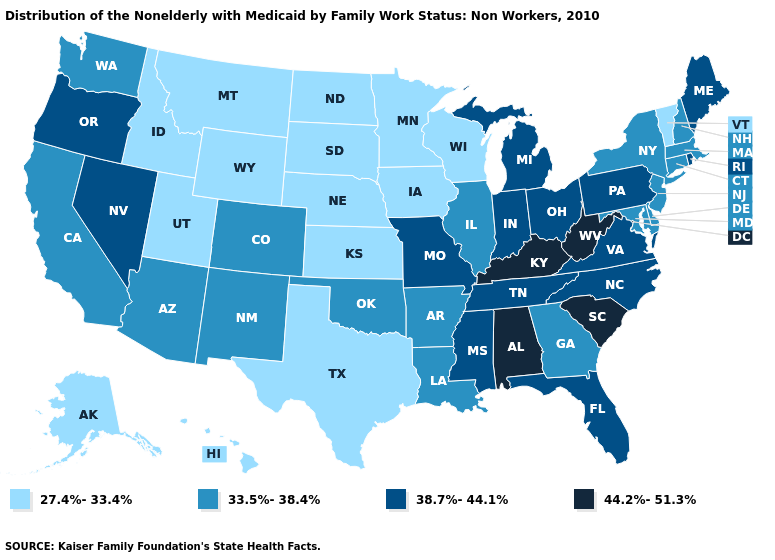Which states have the highest value in the USA?
Short answer required. Alabama, Kentucky, South Carolina, West Virginia. What is the value of Pennsylvania?
Give a very brief answer. 38.7%-44.1%. Does New York have the same value as Massachusetts?
Quick response, please. Yes. What is the value of Delaware?
Concise answer only. 33.5%-38.4%. Among the states that border Kentucky , which have the lowest value?
Short answer required. Illinois. Which states have the lowest value in the USA?
Keep it brief. Alaska, Hawaii, Idaho, Iowa, Kansas, Minnesota, Montana, Nebraska, North Dakota, South Dakota, Texas, Utah, Vermont, Wisconsin, Wyoming. Name the states that have a value in the range 38.7%-44.1%?
Answer briefly. Florida, Indiana, Maine, Michigan, Mississippi, Missouri, Nevada, North Carolina, Ohio, Oregon, Pennsylvania, Rhode Island, Tennessee, Virginia. What is the value of Maine?
Quick response, please. 38.7%-44.1%. Name the states that have a value in the range 33.5%-38.4%?
Write a very short answer. Arizona, Arkansas, California, Colorado, Connecticut, Delaware, Georgia, Illinois, Louisiana, Maryland, Massachusetts, New Hampshire, New Jersey, New Mexico, New York, Oklahoma, Washington. Does the first symbol in the legend represent the smallest category?
Answer briefly. Yes. Does Nevada have the highest value in the USA?
Give a very brief answer. No. Which states hav the highest value in the Northeast?
Answer briefly. Maine, Pennsylvania, Rhode Island. Name the states that have a value in the range 33.5%-38.4%?
Short answer required. Arizona, Arkansas, California, Colorado, Connecticut, Delaware, Georgia, Illinois, Louisiana, Maryland, Massachusetts, New Hampshire, New Jersey, New Mexico, New York, Oklahoma, Washington. 